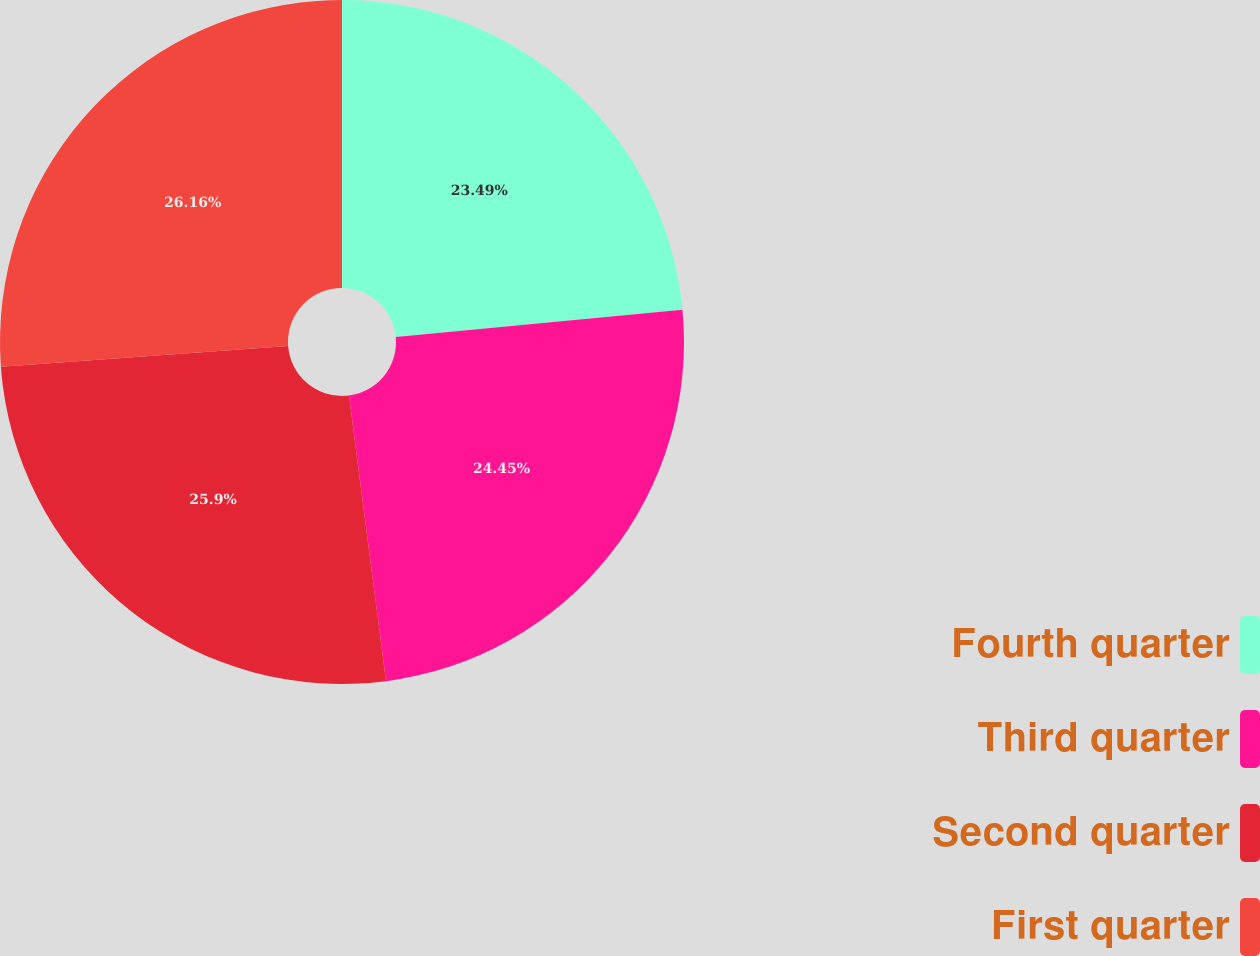<chart> <loc_0><loc_0><loc_500><loc_500><pie_chart><fcel>Fourth quarter<fcel>Third quarter<fcel>Second quarter<fcel>First quarter<nl><fcel>23.49%<fcel>24.45%<fcel>25.9%<fcel>26.15%<nl></chart> 